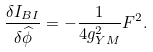<formula> <loc_0><loc_0><loc_500><loc_500>\frac { \delta I _ { B I } } { \delta \widehat { \phi } } = - \frac { 1 } { 4 g _ { Y M } ^ { 2 } } F ^ { 2 } .</formula> 